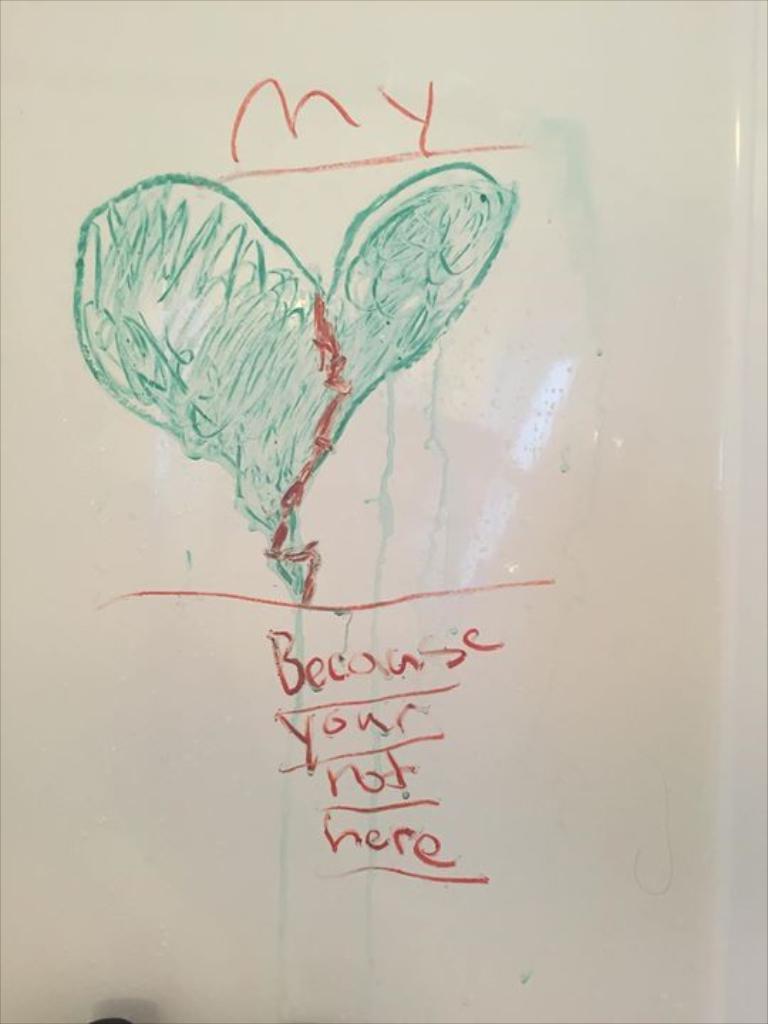Who is not here?
Ensure brevity in your answer.  You. 